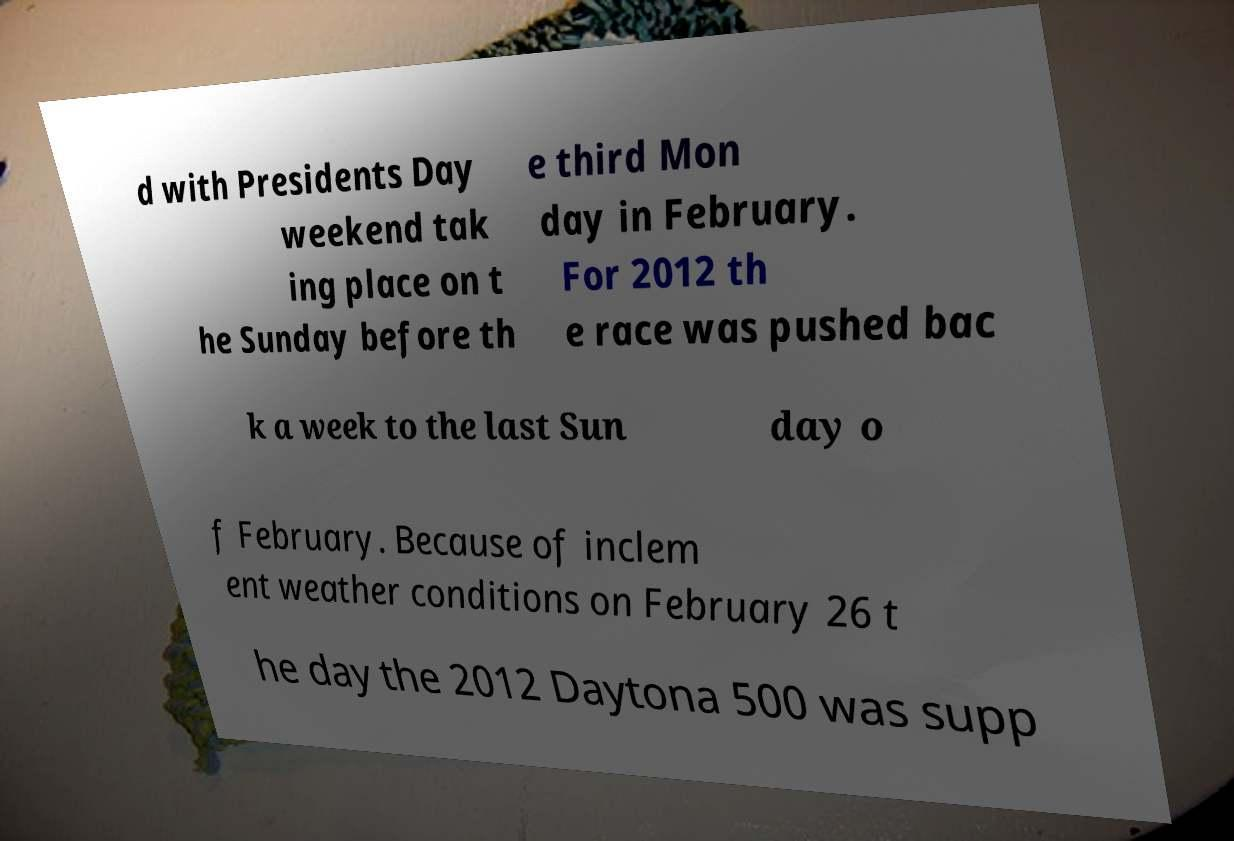Please identify and transcribe the text found in this image. d with Presidents Day weekend tak ing place on t he Sunday before th e third Mon day in February. For 2012 th e race was pushed bac k a week to the last Sun day o f February. Because of inclem ent weather conditions on February 26 t he day the 2012 Daytona 500 was supp 